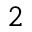<formula> <loc_0><loc_0><loc_500><loc_500>^ { 2 }</formula> 